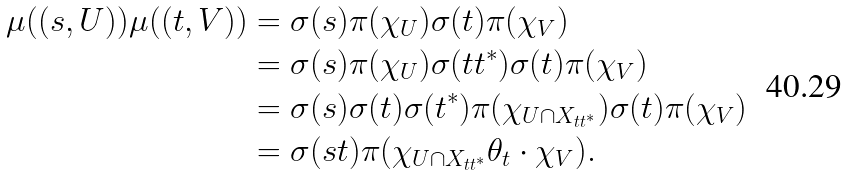<formula> <loc_0><loc_0><loc_500><loc_500>\mu ( ( s , U ) ) \mu ( ( t , V ) ) & = \sigma ( s ) \pi ( \chi _ { U } ) \sigma ( t ) \pi ( \chi _ { V } ) \\ & = \sigma ( s ) \pi ( \chi _ { U } ) \sigma ( t t ^ { * } ) \sigma ( t ) \pi ( \chi _ { V } ) \\ & = \sigma ( s ) \sigma ( t ) \sigma ( t ^ { * } ) \pi ( \chi _ { U \cap X _ { t t ^ { * } } } ) \sigma ( t ) \pi ( \chi _ { V } ) \\ & = \sigma ( s t ) \pi ( \chi _ { U \cap X _ { t t ^ { * } } } \theta _ { t } \cdot \chi _ { V } ) .</formula> 